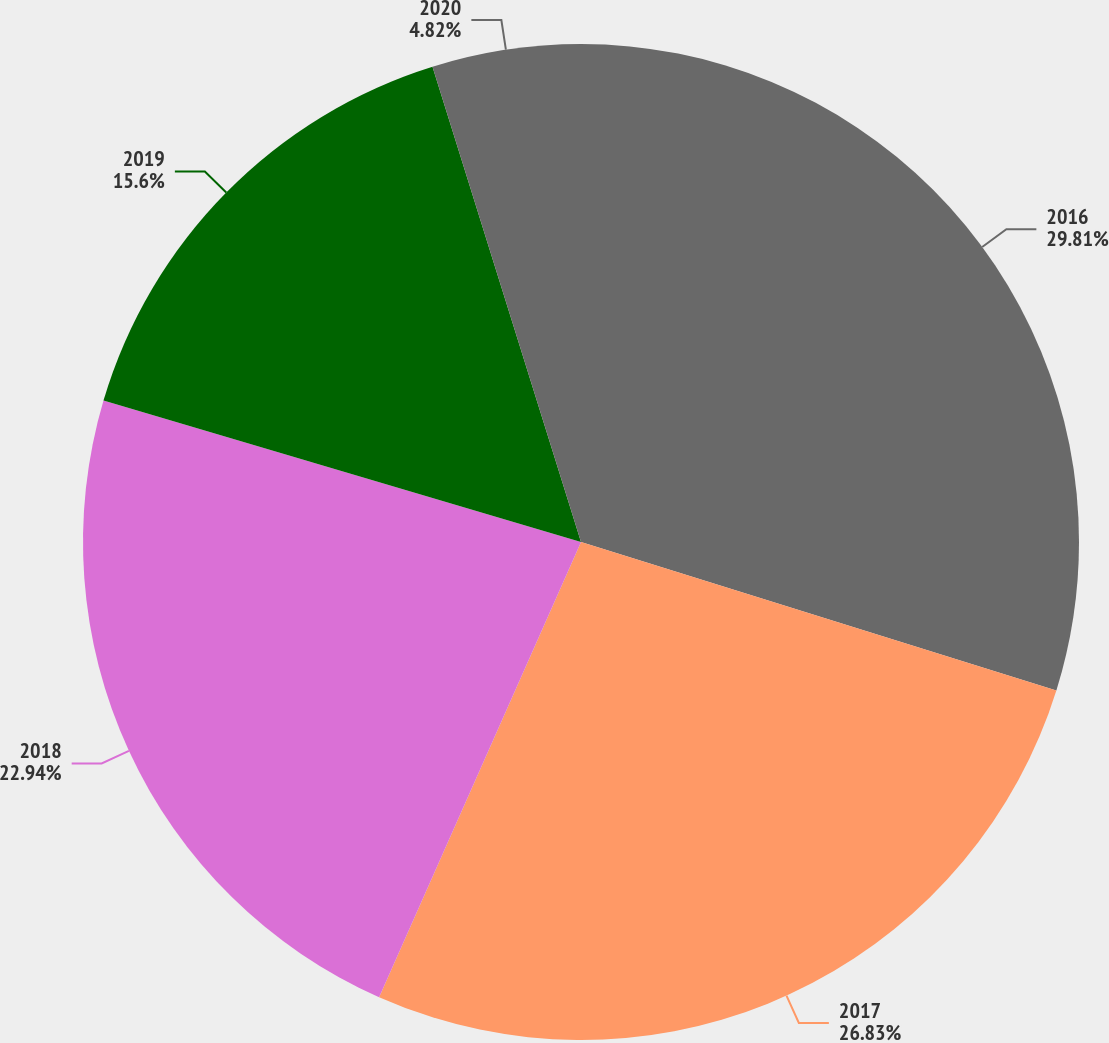Convert chart to OTSL. <chart><loc_0><loc_0><loc_500><loc_500><pie_chart><fcel>2016<fcel>2017<fcel>2018<fcel>2019<fcel>2020<nl><fcel>29.82%<fcel>26.83%<fcel>22.94%<fcel>15.6%<fcel>4.82%<nl></chart> 